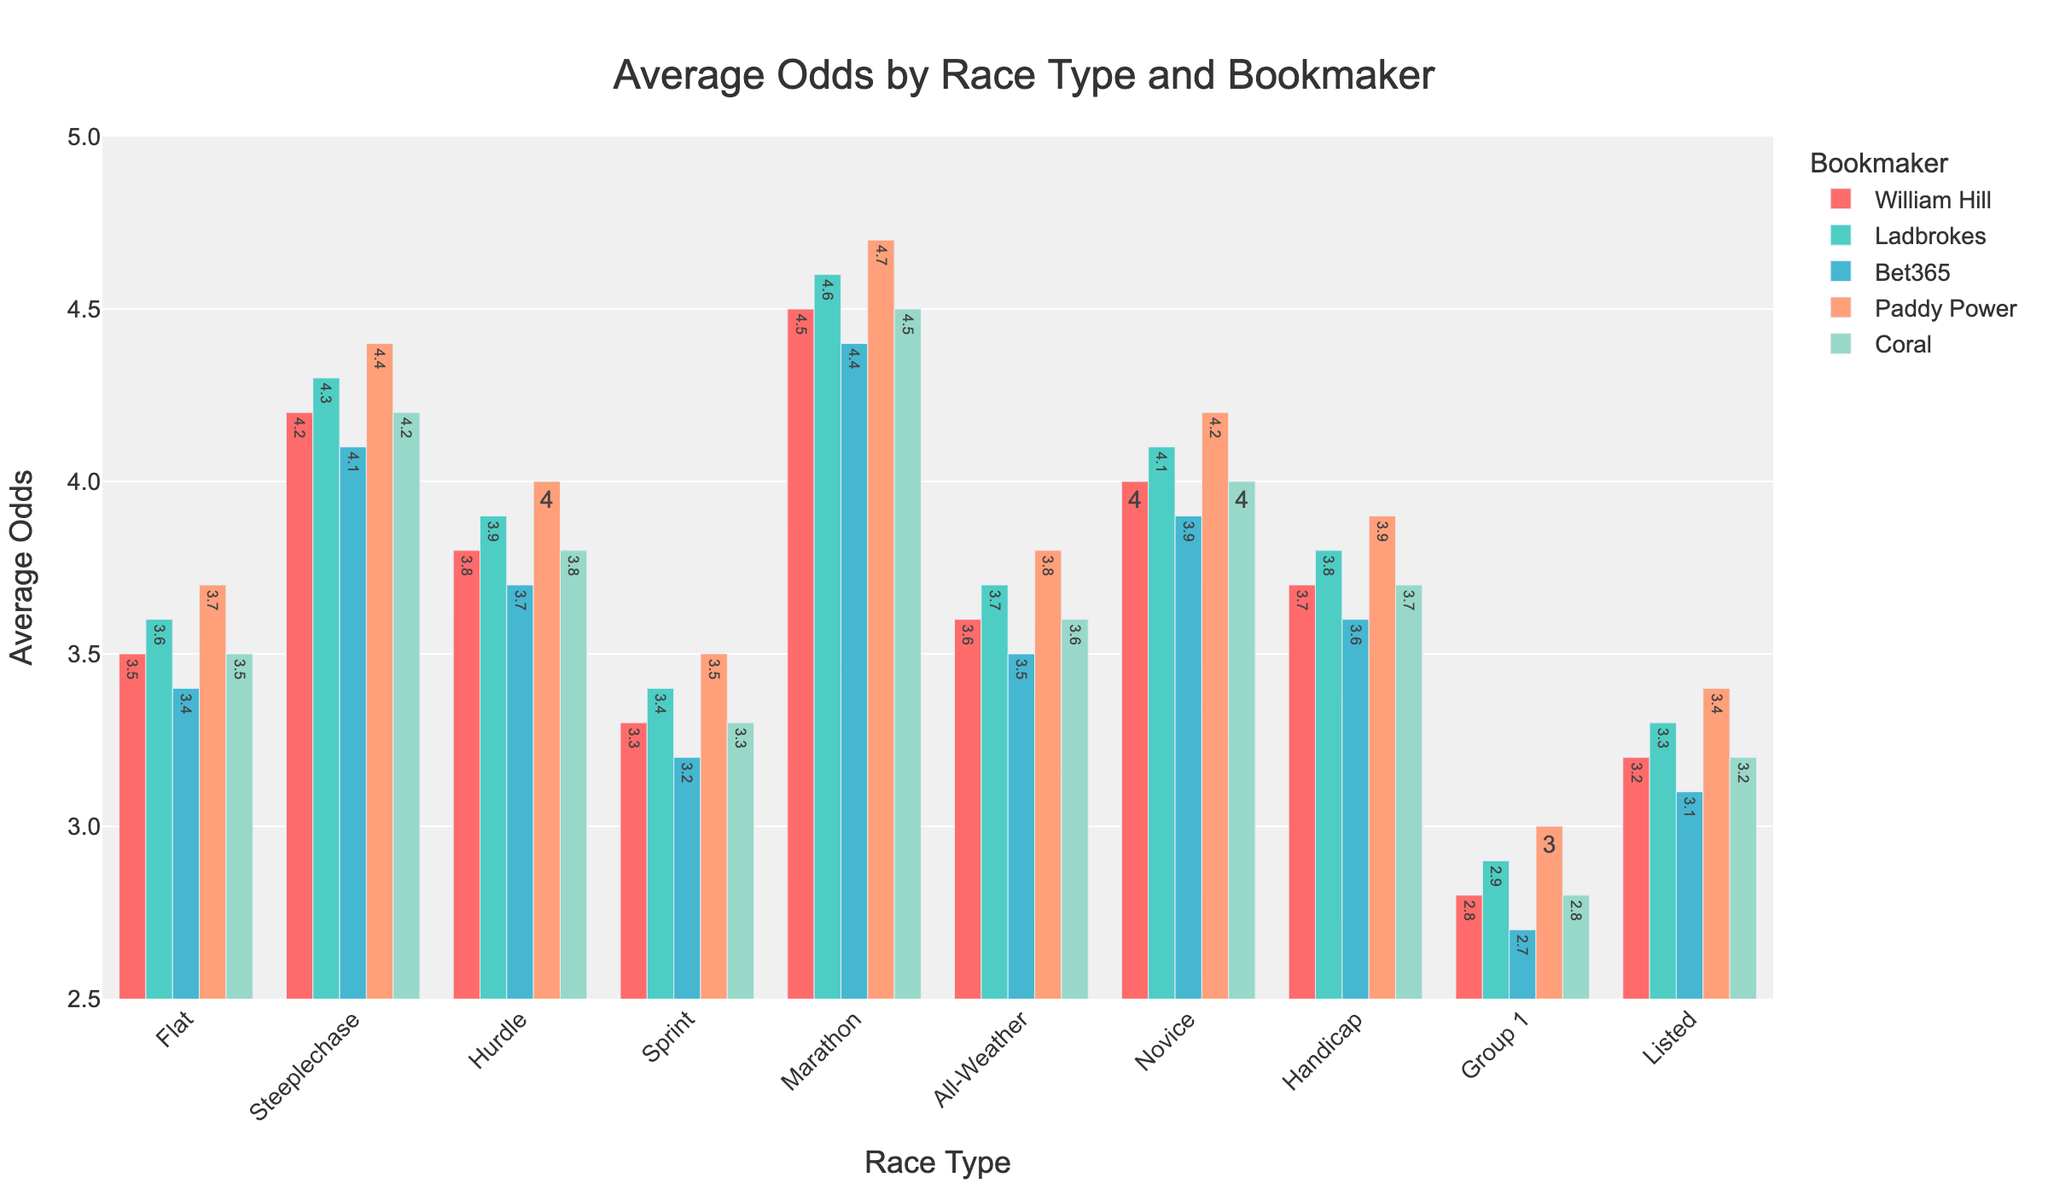Which bookmaker offers the highest average odds for the flat race type? Looking at the flat race type, the bars for each bookmaker indicate their respective odds. The highest bar corresponds to Paddy Power with odds of 3.7.
Answer: Paddy Power How much higher are the odds for a steeplechase given by William Hill compared to the odds for a flat race given by Ladbrokes? The odds for a steeplechase by William Hill are 4.2, and for a flat race by Ladbrokes, they are 3.6. The difference is 4.2 - 3.6 = 0.6.
Answer: 0.6 Which race type has the lowest odds offered by Bet365, and what are those odds? By examining the bars for Bet365 across all race types, the Group 1 race type has the lowest odds at 2.7.
Answer: Group 1, 2.7 What's the average of the highest odds offered by each bookmaker across all race types? First, identify the highest odds offered by each bookmaker: William Hill (4.5), Ladbrokes (4.6), Bet365 (4.4), Paddy Power (4.7), Coral (4.5). The average is (4.5 + 4.6 + 4.4 + 4.7 + 4.5) / 5 = 4.54.
Answer: 4.54 Which race type shows the smallest difference between the highest and lowest odds offered, and what is that difference? Calculate the difference for each race type: 
- Flat: 3.7 - 3.4 = 0.3
- Steeplechase: 4.4 - 4.1 = 0.3
- Hurdle: 4.0 - 3.7 = 0.3
- Sprint: 3.5 - 3.2 = 0.3
- Marathon: 4.7 - 4.4 = 0.3
- All-Weather: 3.8 - 3.5 = 0.3
- Novice: 4.2 - 3.9 = 0.3
- Handicap: 3.9 - 3.6 = 0.3
- Group 1: 3.0 - 2.7 = 0.3
- Listed: 3.4 - 3.1 = 0.3
All differences are the same (0.3), so all race types show a difference of 0.3.
Answer: All race types, 0.3 Which bookmaker provides consistently the second-highest odds across all race types and how do you determine this? Look for the second-highest bar color for each race type: 
- Flat: 3.6 (Ladbrokes)
- Steeplechase: 4.3 (Ladbrokes)
- Hurdle: 3.9 (Ladbrokes)
- Sprint: 3.4 (Ladbrokes)
- Marathon: 4.6 (Ladbrokes)
- All-Weather: 3.7 (Ladbrokes)
- Novice: 4.1 (Ladbrokes)
- Handicap: 3.8 (Ladbrokes)
- Group 1: 2.9 (Ladbrokes)
- Listed: 3.3 (Ladbrokes)
Ladbrokes consistently provides the second-highest odds.
Answer: Ladbrokes 